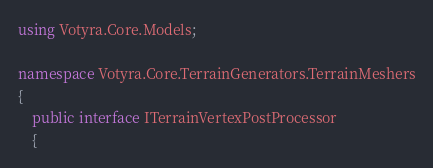<code> <loc_0><loc_0><loc_500><loc_500><_C#_>using Votyra.Core.Models;

namespace Votyra.Core.TerrainGenerators.TerrainMeshers
{
    public interface ITerrainVertexPostProcessor
    {</code> 